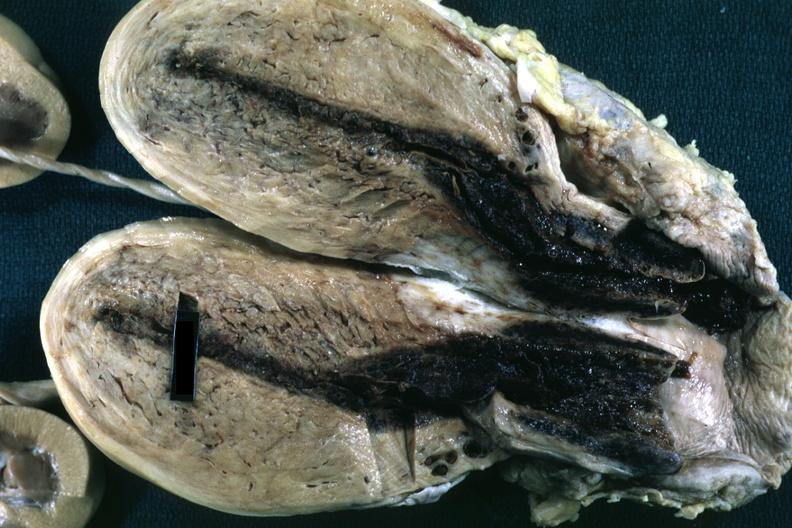how is fixed tissue opened uterus with blood clot in cervical canal and small cavity?
Answer the question using a single word or phrase. Endometrial 